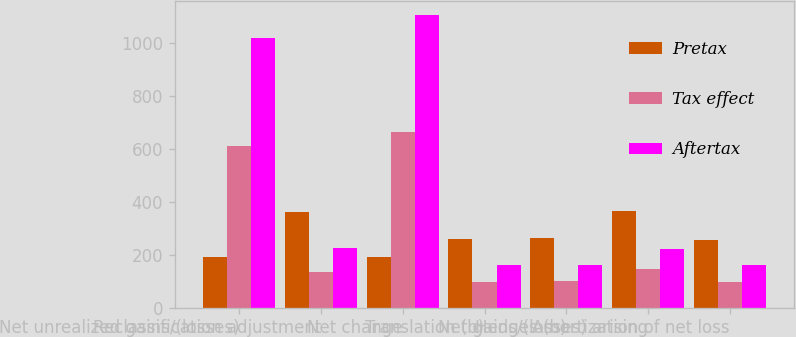Convert chart. <chart><loc_0><loc_0><loc_500><loc_500><stacked_bar_chart><ecel><fcel>Net unrealized gains/(losses)<fcel>Reclassification adjustment<fcel>Net change<fcel>Translation (b)<fcel>Hedges (b)<fcel>Net gains/(losses) arising<fcel>Amortization of net loss<nl><fcel>Pretax<fcel>191.5<fcel>360<fcel>191.5<fcel>261<fcel>262<fcel>366<fcel>257<nl><fcel>Tax effect<fcel>611<fcel>134<fcel>664<fcel>99<fcel>102<fcel>145<fcel>97<nl><fcel>Aftertax<fcel>1017<fcel>226<fcel>1105<fcel>162<fcel>160<fcel>221<fcel>160<nl></chart> 